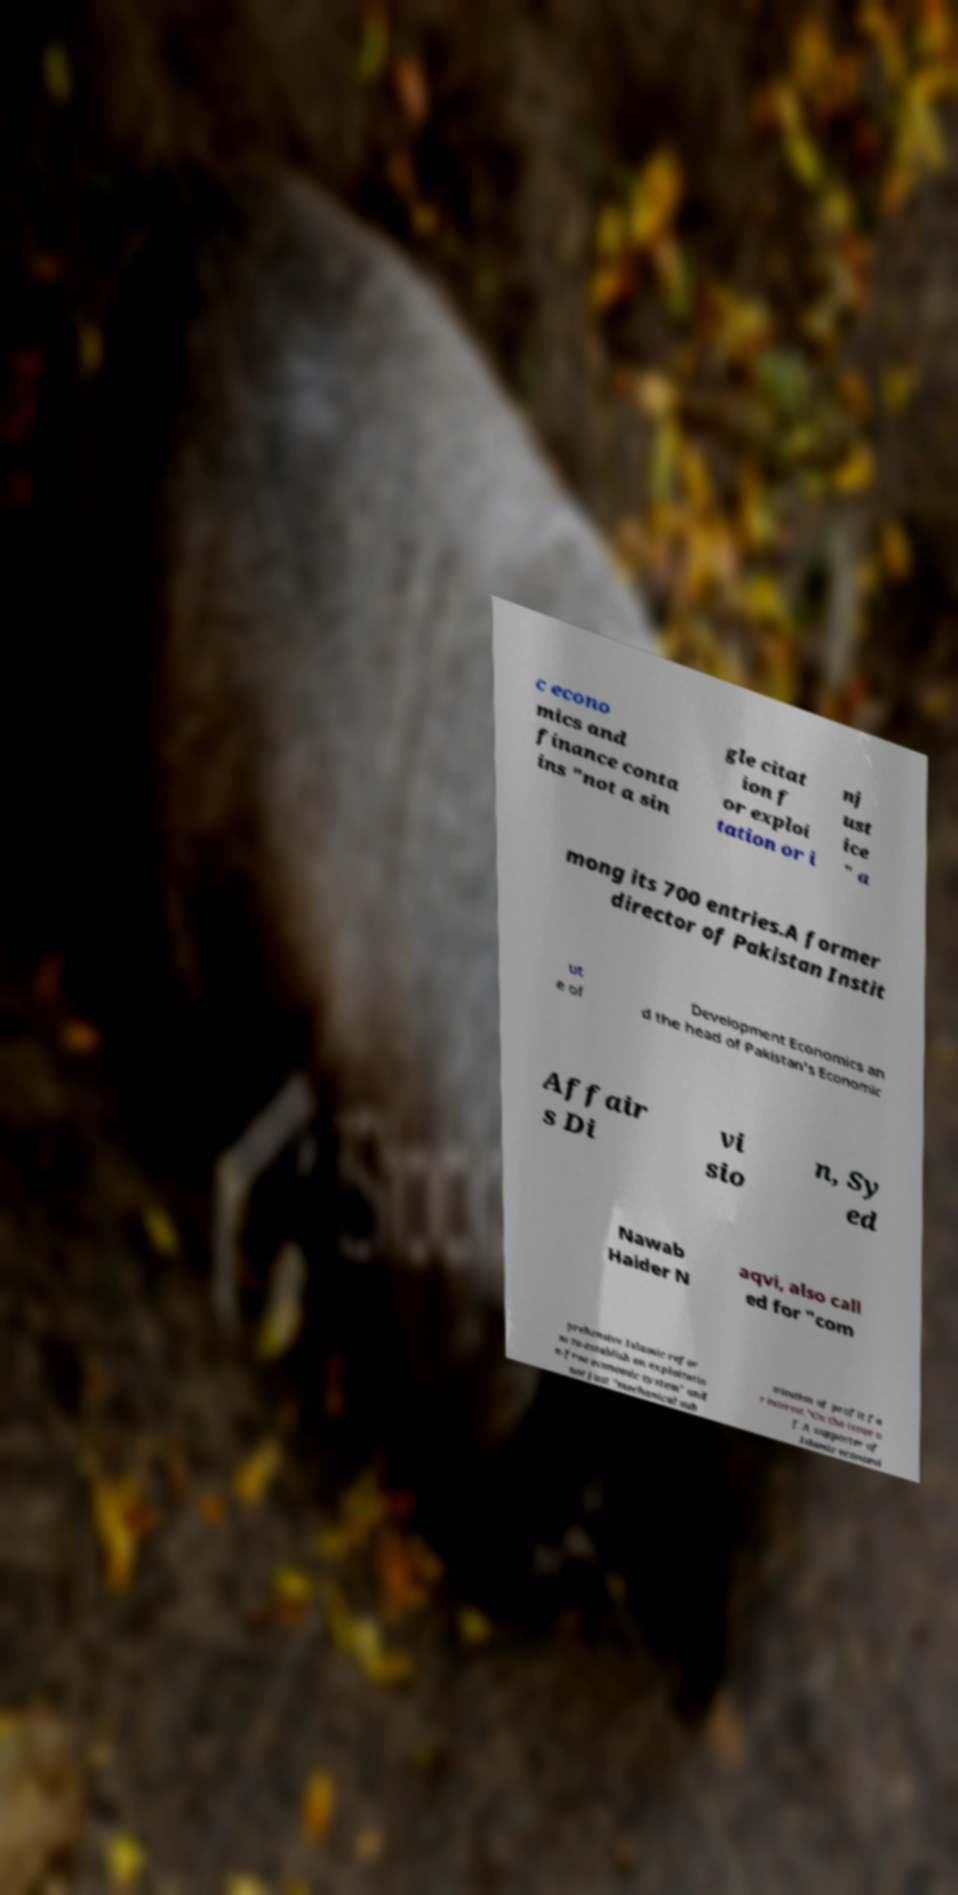Please read and relay the text visible in this image. What does it say? c econo mics and finance conta ins "not a sin gle citat ion f or exploi tation or i nj ust ice " a mong its 700 entries.A former director of Pakistan Instit ut e of Development Economics an d the head of Pakistan's Economic Affair s Di vi sio n, Sy ed Nawab Haider N aqvi, also call ed for "com prehensive Islamic refor m to establish an exploitatio n-free economic system" and not just "mechanical sub stitution of profit fo r interest."On the issue o f A supporter of Islamic economi 